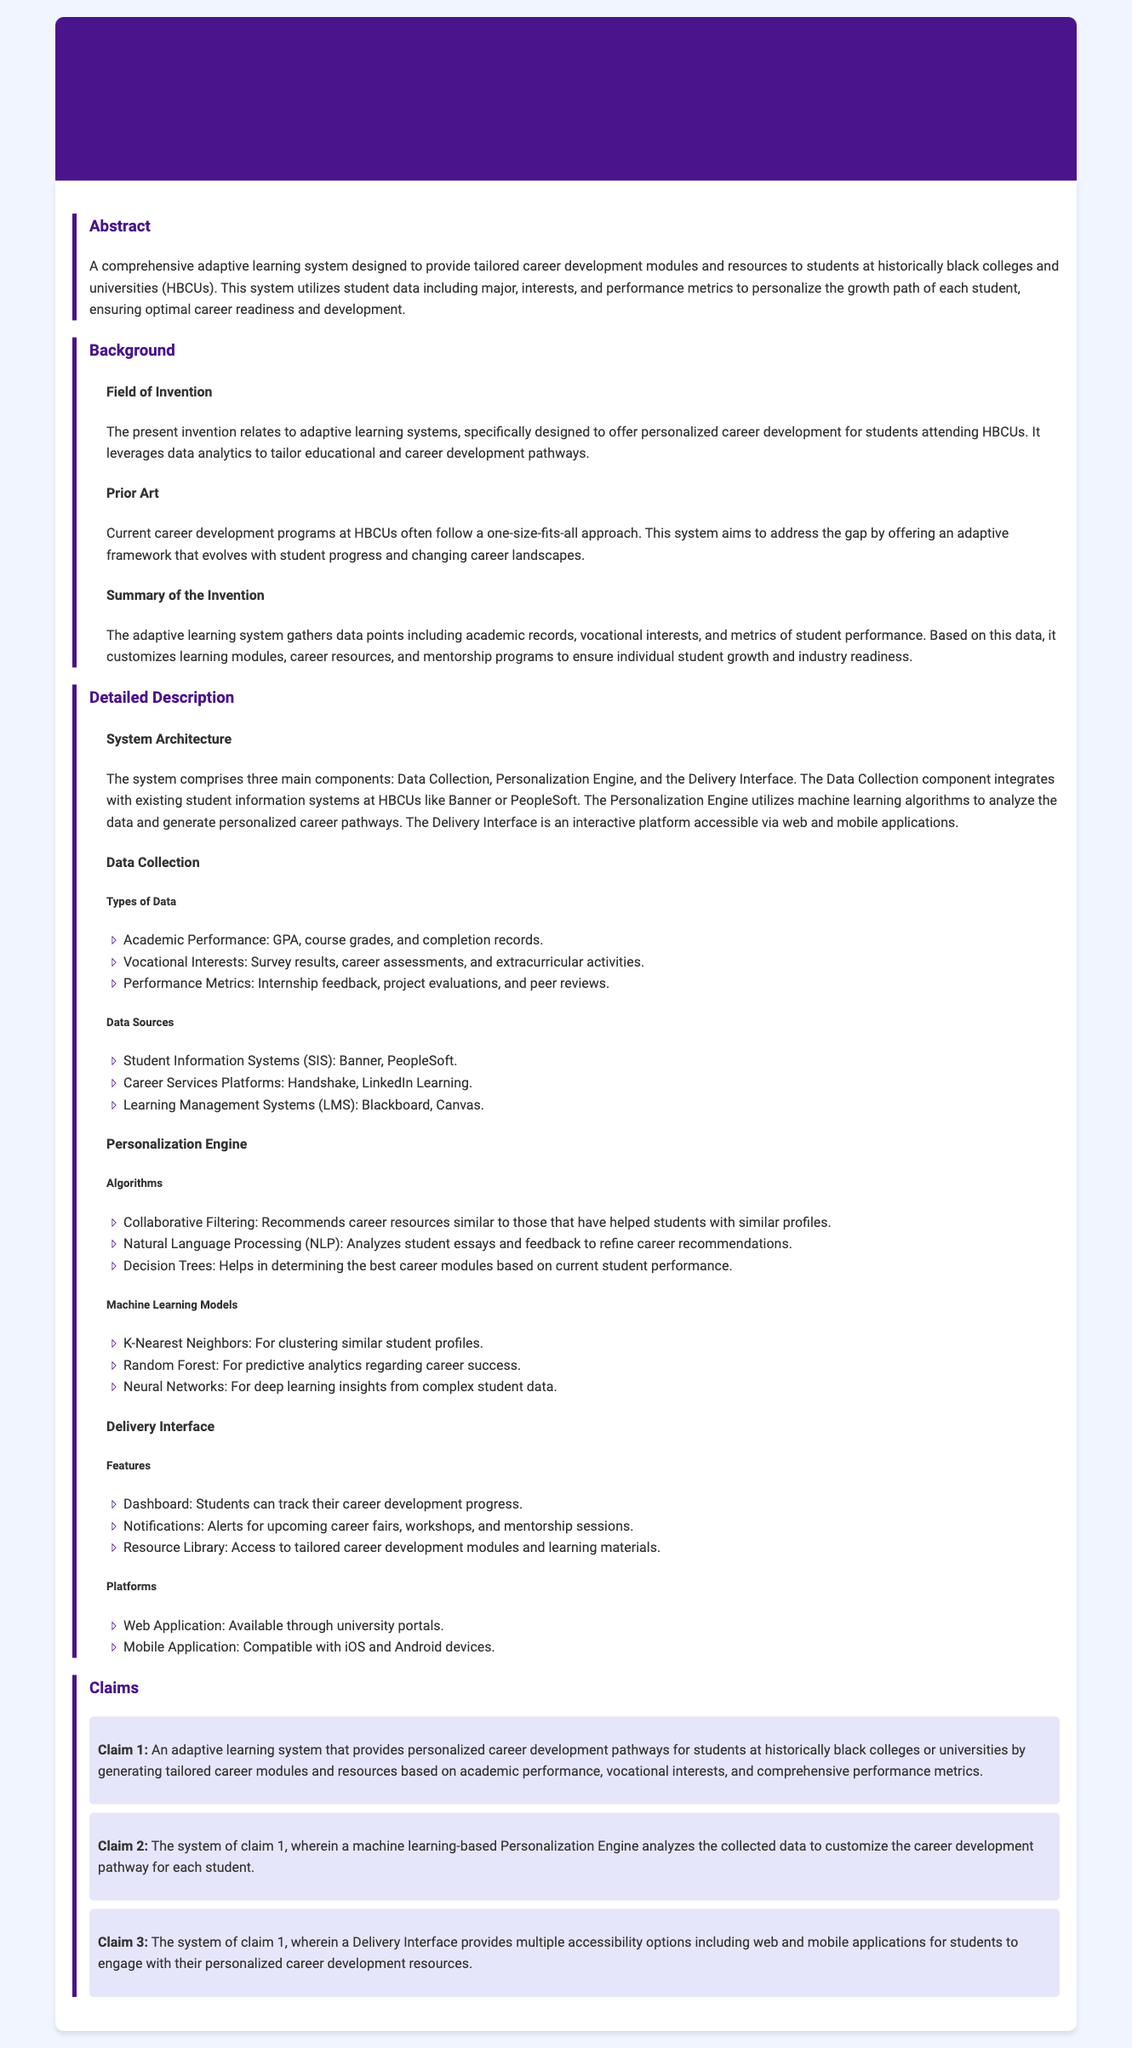What is the title of the patent application? The title appears prominently at the top of the document, indicating the specific focus of the patent.
Answer: Adaptive Learning System for Personalized Career Development What type of educational institutions does the system target? The abstract states that the system is designed specifically for students at a certain type of college.
Answer: Historically black colleges and universities What does the Personalization Engine utilize to analyze data? The document lists specific technologies that the Personalization Engine employs for data analysis.
Answer: Machine learning algorithms Which data is collected regarding academic performance? The types of academic performance data collected are listed in the document.
Answer: GPA, course grades, and completion records What is the main objective of the adaptive learning system? The abstract outlines the primary goal of the system in a concise manner.
Answer: To provide tailored career development modules and resources Which algorithm is used for career resource recommendations? The detailed section mentions a specific method used for making recommendations based on student profiles.
Answer: Collaborative Filtering How many components are in the system's architecture? The detailed description of the system architecture specifies the total number of main components.
Answer: Three What feature helps students track their progress? A specific feature of the Delivery Interface is described that serves this purpose.
Answer: Dashboard 